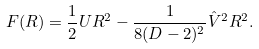Convert formula to latex. <formula><loc_0><loc_0><loc_500><loc_500>F ( R ) = \frac { 1 } { 2 } U R ^ { 2 } - \frac { 1 } { 8 ( D - 2 ) ^ { 2 } } \hat { V } ^ { 2 } R ^ { 2 } .</formula> 